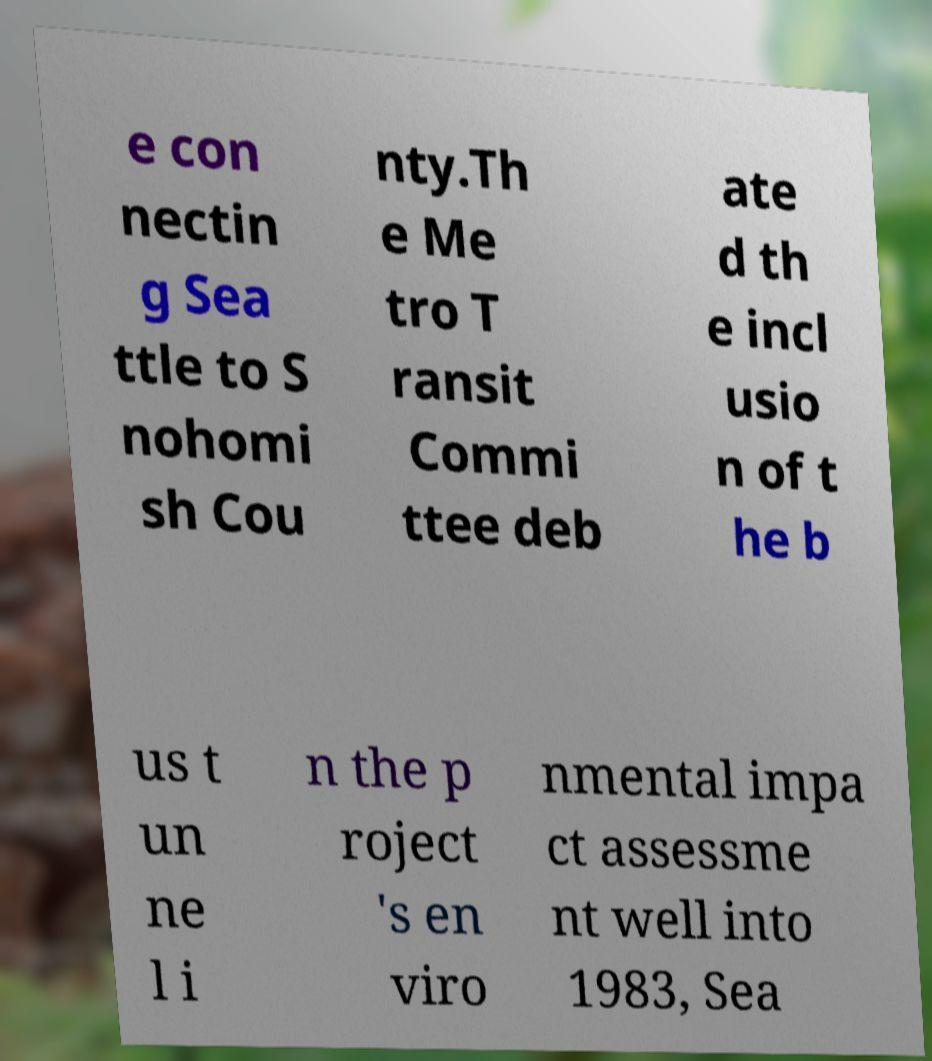Can you accurately transcribe the text from the provided image for me? e con nectin g Sea ttle to S nohomi sh Cou nty.Th e Me tro T ransit Commi ttee deb ate d th e incl usio n of t he b us t un ne l i n the p roject 's en viro nmental impa ct assessme nt well into 1983, Sea 